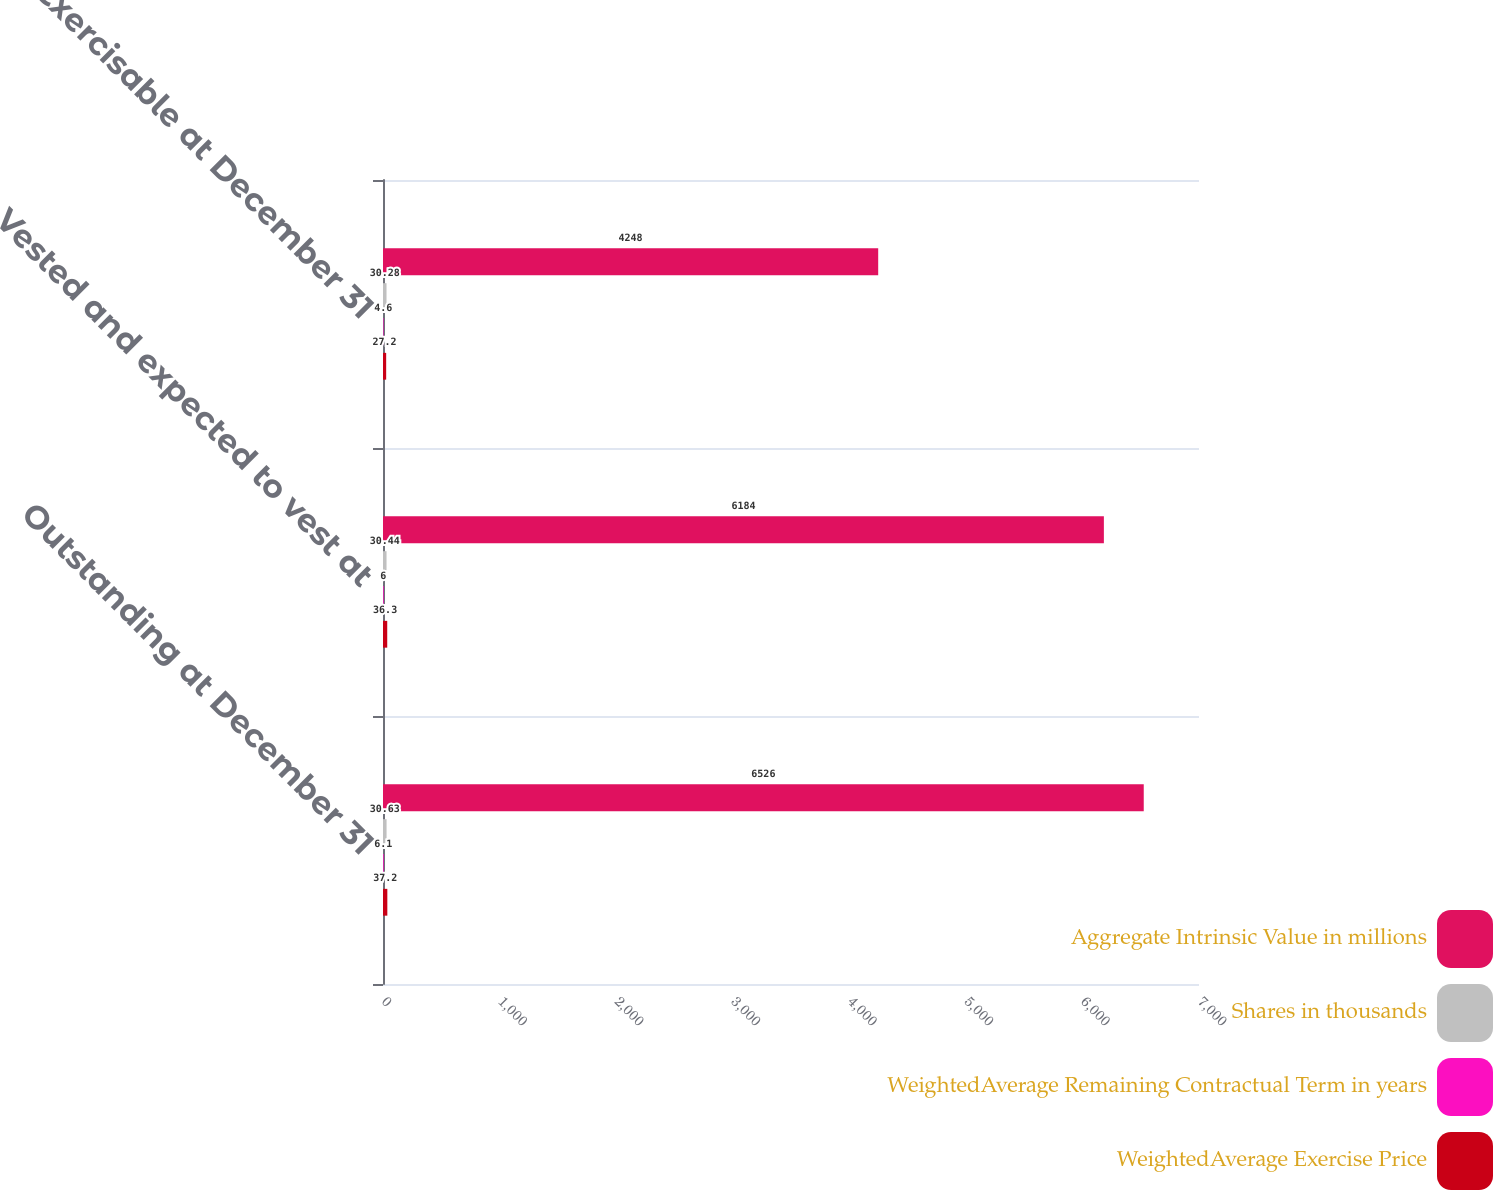Convert chart to OTSL. <chart><loc_0><loc_0><loc_500><loc_500><stacked_bar_chart><ecel><fcel>Outstanding at December 31<fcel>Vested and expected to vest at<fcel>Exercisable at December 31<nl><fcel>Aggregate Intrinsic Value in millions<fcel>6526<fcel>6184<fcel>4248<nl><fcel>Shares in thousands<fcel>30.63<fcel>30.44<fcel>30.28<nl><fcel>WeightedAverage Remaining Contractual Term in years<fcel>6.1<fcel>6<fcel>4.6<nl><fcel>WeightedAverage Exercise Price<fcel>37.2<fcel>36.3<fcel>27.2<nl></chart> 